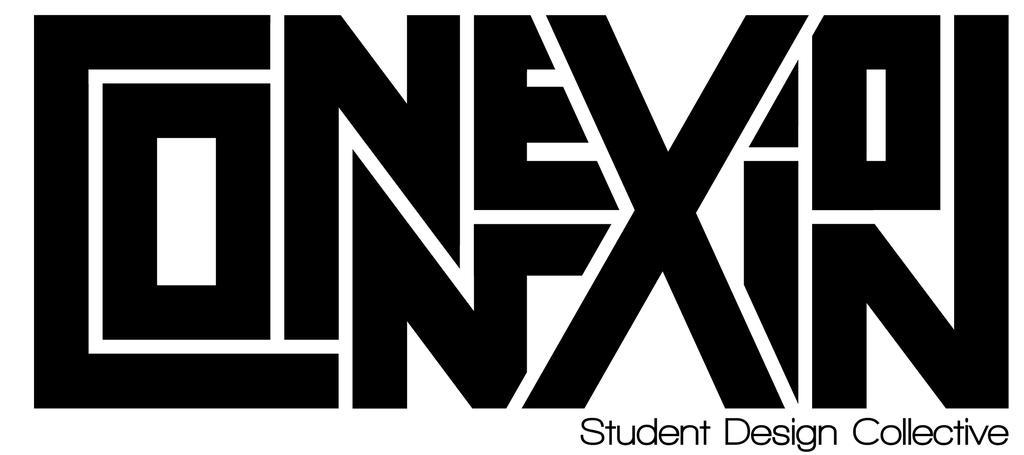Describe this image in one or two sentences. In this picture, we see some text written in black color. At the bottom, it is written as "Student Design Collectives". In the background, it is white in color. This might be a board. 